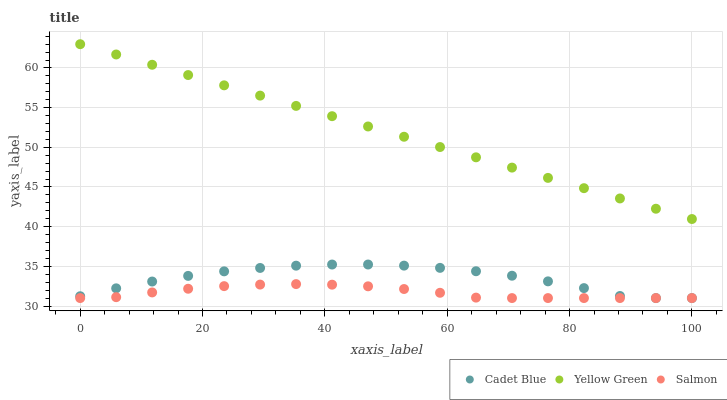Does Salmon have the minimum area under the curve?
Answer yes or no. Yes. Does Yellow Green have the maximum area under the curve?
Answer yes or no. Yes. Does Yellow Green have the minimum area under the curve?
Answer yes or no. No. Does Salmon have the maximum area under the curve?
Answer yes or no. No. Is Yellow Green the smoothest?
Answer yes or no. Yes. Is Cadet Blue the roughest?
Answer yes or no. Yes. Is Salmon the smoothest?
Answer yes or no. No. Is Salmon the roughest?
Answer yes or no. No. Does Cadet Blue have the lowest value?
Answer yes or no. Yes. Does Yellow Green have the lowest value?
Answer yes or no. No. Does Yellow Green have the highest value?
Answer yes or no. Yes. Does Salmon have the highest value?
Answer yes or no. No. Is Cadet Blue less than Yellow Green?
Answer yes or no. Yes. Is Yellow Green greater than Cadet Blue?
Answer yes or no. Yes. Does Salmon intersect Cadet Blue?
Answer yes or no. Yes. Is Salmon less than Cadet Blue?
Answer yes or no. No. Is Salmon greater than Cadet Blue?
Answer yes or no. No. Does Cadet Blue intersect Yellow Green?
Answer yes or no. No. 